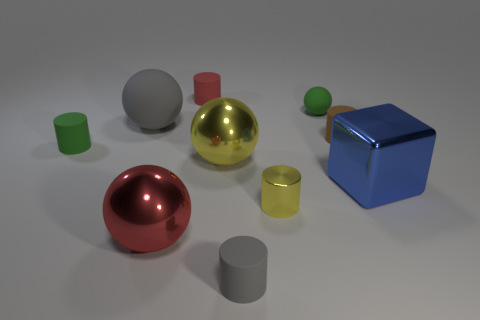Subtract all gray cylinders. How many cylinders are left? 4 Subtract all small green cylinders. How many cylinders are left? 4 Subtract all cyan cylinders. Subtract all green spheres. How many cylinders are left? 5 Subtract all blocks. How many objects are left? 9 Subtract 1 gray cylinders. How many objects are left? 9 Subtract all red cylinders. Subtract all metal spheres. How many objects are left? 7 Add 6 big yellow things. How many big yellow things are left? 7 Add 8 small green metal cylinders. How many small green metal cylinders exist? 8 